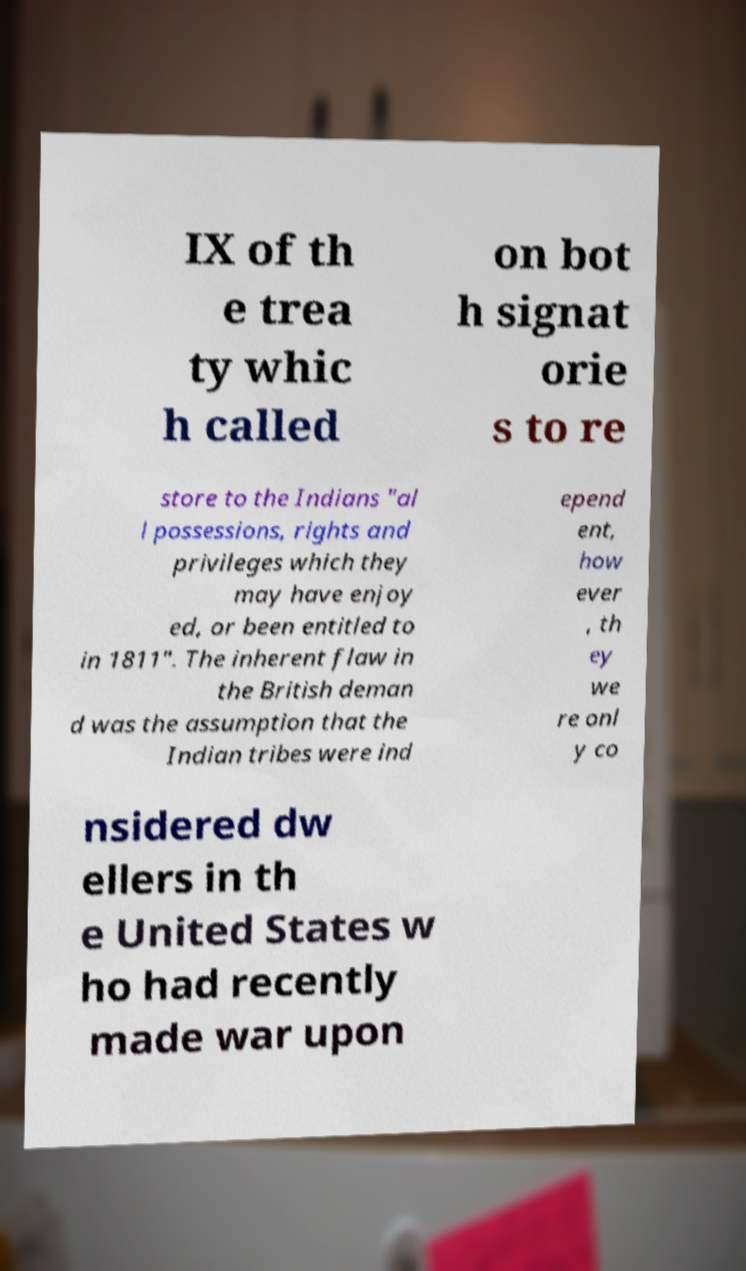I need the written content from this picture converted into text. Can you do that? IX of th e trea ty whic h called on bot h signat orie s to re store to the Indians "al l possessions, rights and privileges which they may have enjoy ed, or been entitled to in 1811". The inherent flaw in the British deman d was the assumption that the Indian tribes were ind epend ent, how ever , th ey we re onl y co nsidered dw ellers in th e United States w ho had recently made war upon 